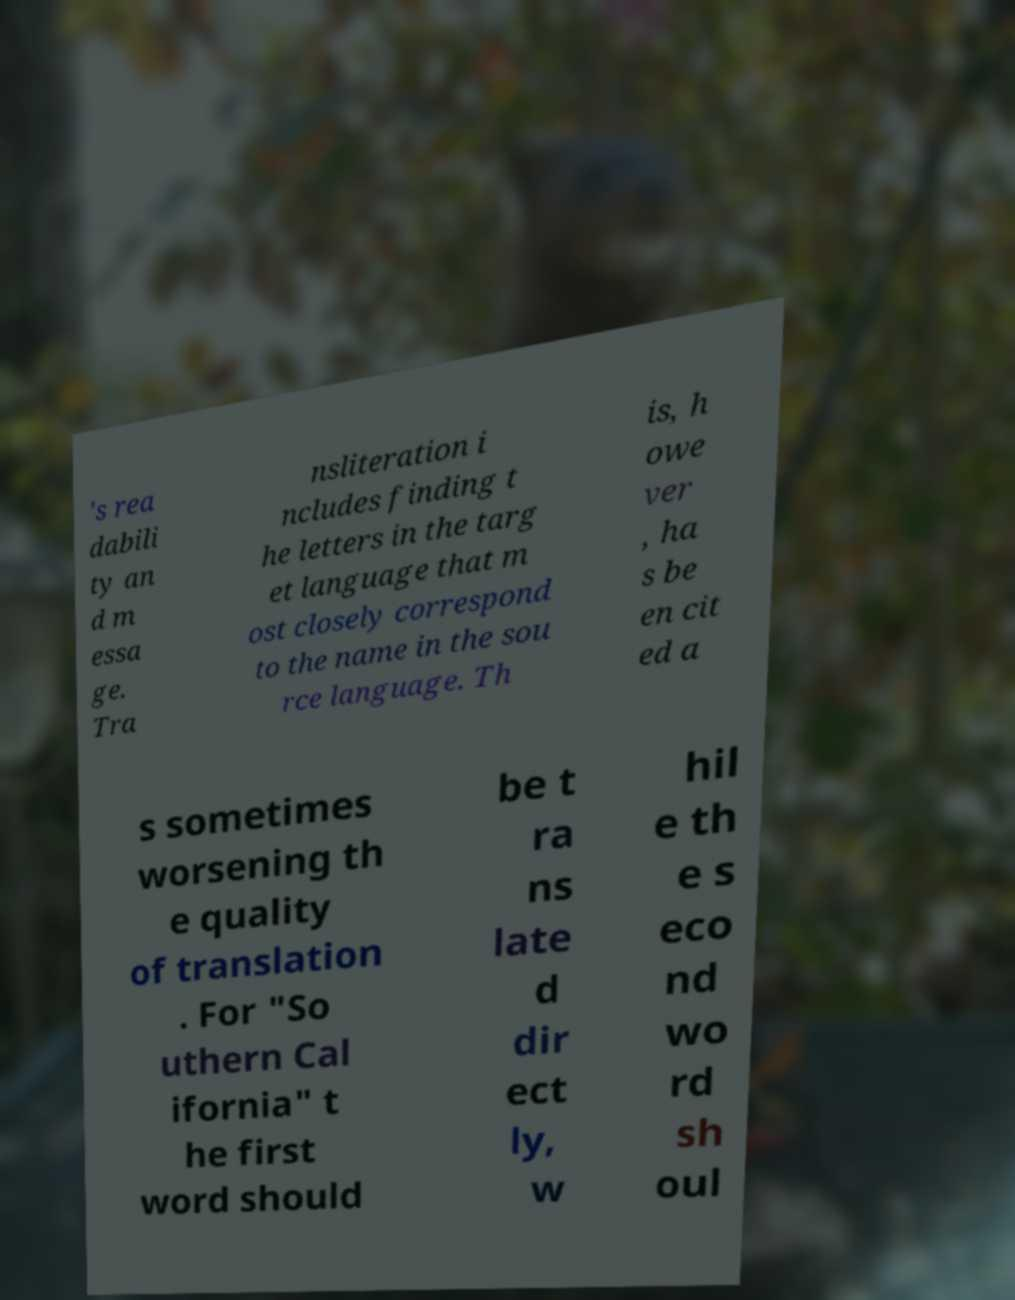What messages or text are displayed in this image? I need them in a readable, typed format. 's rea dabili ty an d m essa ge. Tra nsliteration i ncludes finding t he letters in the targ et language that m ost closely correspond to the name in the sou rce language. Th is, h owe ver , ha s be en cit ed a s sometimes worsening th e quality of translation . For "So uthern Cal ifornia" t he first word should be t ra ns late d dir ect ly, w hil e th e s eco nd wo rd sh oul 